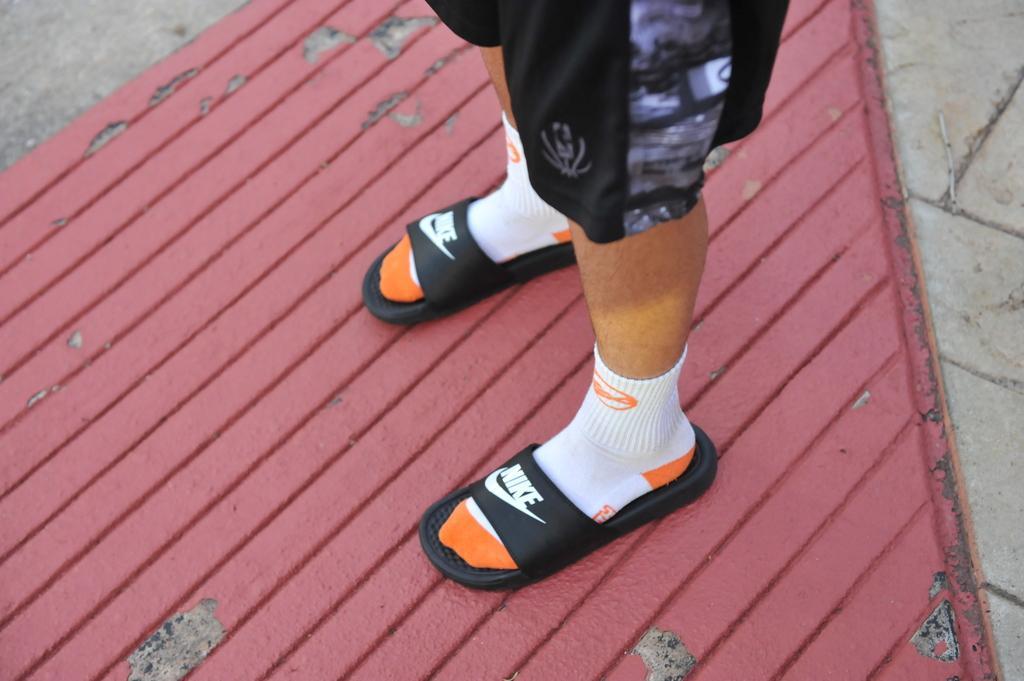How would you summarize this image in a sentence or two? In this picture I can see there is a person standing, wearing a trouser it is in black color, socks which are in white and orange color and slippers they are in black color. The floor is painted with a maroon color. 